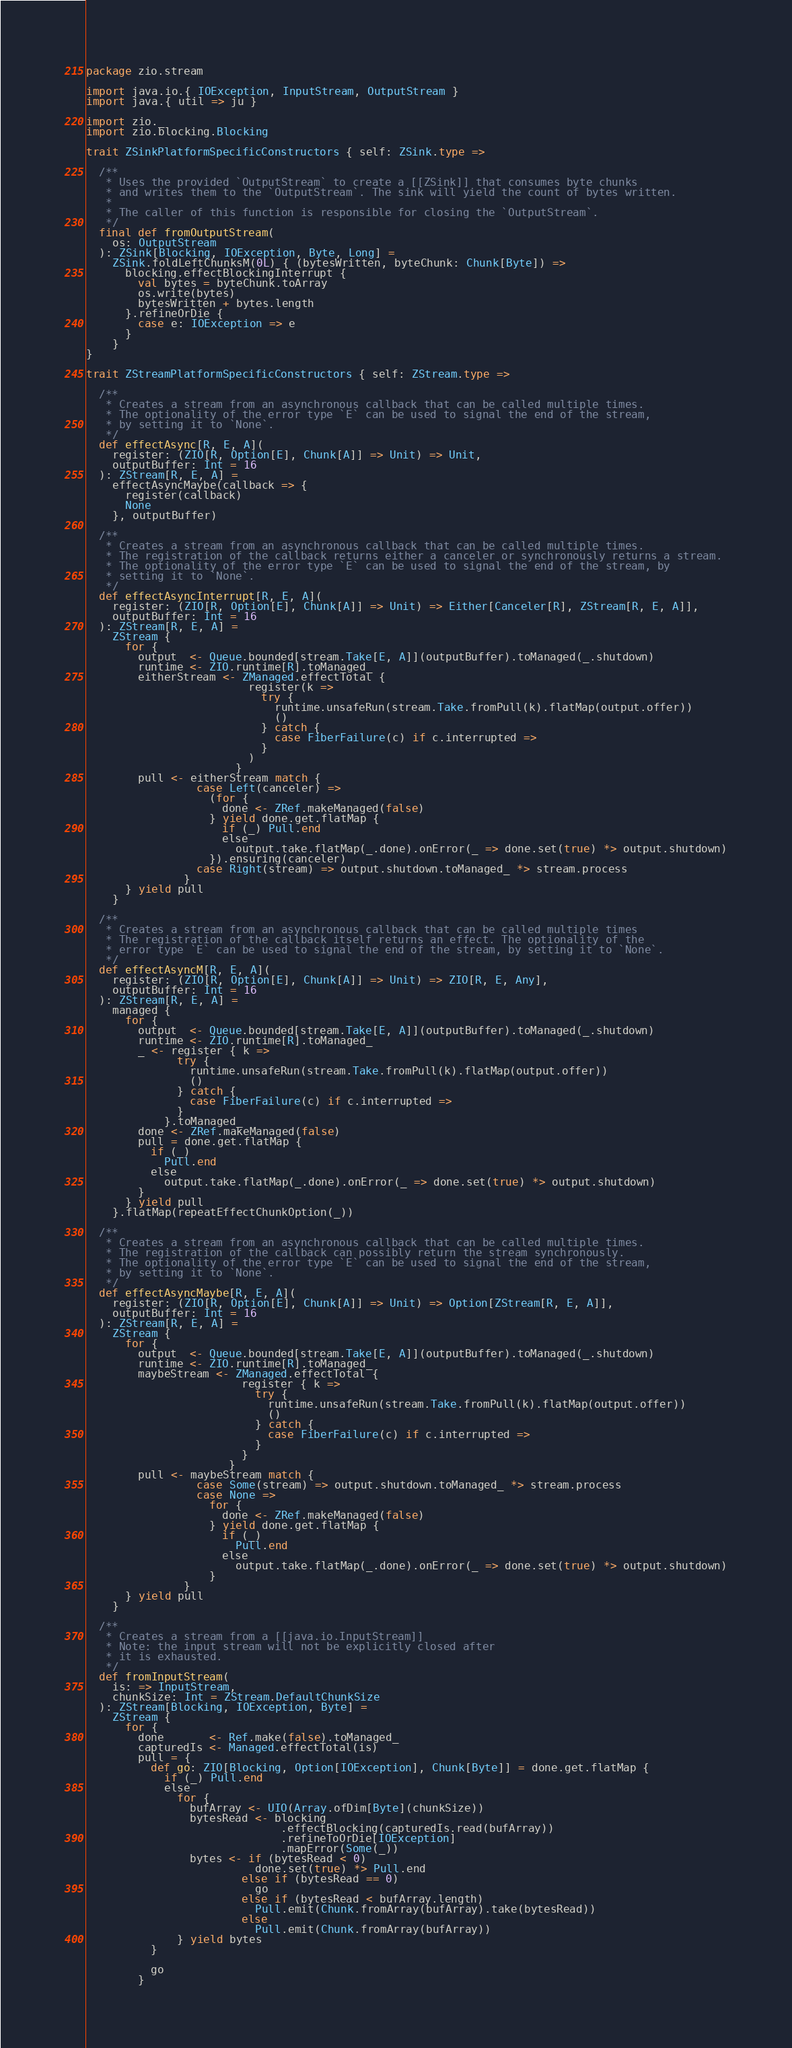Convert code to text. <code><loc_0><loc_0><loc_500><loc_500><_Scala_>package zio.stream

import java.io.{ IOException, InputStream, OutputStream }
import java.{ util => ju }

import zio._
import zio.blocking.Blocking

trait ZSinkPlatformSpecificConstructors { self: ZSink.type =>

  /**
   * Uses the provided `OutputStream` to create a [[ZSink]] that consumes byte chunks
   * and writes them to the `OutputStream`. The sink will yield the count of bytes written.
   *
   * The caller of this function is responsible for closing the `OutputStream`.
   */
  final def fromOutputStream(
    os: OutputStream
  ): ZSink[Blocking, IOException, Byte, Long] =
    ZSink.foldLeftChunksM(0L) { (bytesWritten, byteChunk: Chunk[Byte]) =>
      blocking.effectBlockingInterrupt {
        val bytes = byteChunk.toArray
        os.write(bytes)
        bytesWritten + bytes.length
      }.refineOrDie {
        case e: IOException => e
      }
    }
}

trait ZStreamPlatformSpecificConstructors { self: ZStream.type =>

  /**
   * Creates a stream from an asynchronous callback that can be called multiple times.
   * The optionality of the error type `E` can be used to signal the end of the stream,
   * by setting it to `None`.
   */
  def effectAsync[R, E, A](
    register: (ZIO[R, Option[E], Chunk[A]] => Unit) => Unit,
    outputBuffer: Int = 16
  ): ZStream[R, E, A] =
    effectAsyncMaybe(callback => {
      register(callback)
      None
    }, outputBuffer)

  /**
   * Creates a stream from an asynchronous callback that can be called multiple times.
   * The registration of the callback returns either a canceler or synchronously returns a stream.
   * The optionality of the error type `E` can be used to signal the end of the stream, by
   * setting it to `None`.
   */
  def effectAsyncInterrupt[R, E, A](
    register: (ZIO[R, Option[E], Chunk[A]] => Unit) => Either[Canceler[R], ZStream[R, E, A]],
    outputBuffer: Int = 16
  ): ZStream[R, E, A] =
    ZStream {
      for {
        output  <- Queue.bounded[stream.Take[E, A]](outputBuffer).toManaged(_.shutdown)
        runtime <- ZIO.runtime[R].toManaged_
        eitherStream <- ZManaged.effectTotal {
                         register(k =>
                           try {
                             runtime.unsafeRun(stream.Take.fromPull(k).flatMap(output.offer))
                             ()
                           } catch {
                             case FiberFailure(c) if c.interrupted =>
                           }
                         )
                       }
        pull <- eitherStream match {
                 case Left(canceler) =>
                   (for {
                     done <- ZRef.makeManaged(false)
                   } yield done.get.flatMap {
                     if (_) Pull.end
                     else
                       output.take.flatMap(_.done).onError(_ => done.set(true) *> output.shutdown)
                   }).ensuring(canceler)
                 case Right(stream) => output.shutdown.toManaged_ *> stream.process
               }
      } yield pull
    }

  /**
   * Creates a stream from an asynchronous callback that can be called multiple times
   * The registration of the callback itself returns an effect. The optionality of the
   * error type `E` can be used to signal the end of the stream, by setting it to `None`.
   */
  def effectAsyncM[R, E, A](
    register: (ZIO[R, Option[E], Chunk[A]] => Unit) => ZIO[R, E, Any],
    outputBuffer: Int = 16
  ): ZStream[R, E, A] =
    managed {
      for {
        output  <- Queue.bounded[stream.Take[E, A]](outputBuffer).toManaged(_.shutdown)
        runtime <- ZIO.runtime[R].toManaged_
        _ <- register { k =>
              try {
                runtime.unsafeRun(stream.Take.fromPull(k).flatMap(output.offer))
                ()
              } catch {
                case FiberFailure(c) if c.interrupted =>
              }
            }.toManaged_
        done <- ZRef.makeManaged(false)
        pull = done.get.flatMap {
          if (_)
            Pull.end
          else
            output.take.flatMap(_.done).onError(_ => done.set(true) *> output.shutdown)
        }
      } yield pull
    }.flatMap(repeatEffectChunkOption(_))

  /**
   * Creates a stream from an asynchronous callback that can be called multiple times.
   * The registration of the callback can possibly return the stream synchronously.
   * The optionality of the error type `E` can be used to signal the end of the stream,
   * by setting it to `None`.
   */
  def effectAsyncMaybe[R, E, A](
    register: (ZIO[R, Option[E], Chunk[A]] => Unit) => Option[ZStream[R, E, A]],
    outputBuffer: Int = 16
  ): ZStream[R, E, A] =
    ZStream {
      for {
        output  <- Queue.bounded[stream.Take[E, A]](outputBuffer).toManaged(_.shutdown)
        runtime <- ZIO.runtime[R].toManaged_
        maybeStream <- ZManaged.effectTotal {
                        register { k =>
                          try {
                            runtime.unsafeRun(stream.Take.fromPull(k).flatMap(output.offer))
                            ()
                          } catch {
                            case FiberFailure(c) if c.interrupted =>
                          }
                        }
                      }
        pull <- maybeStream match {
                 case Some(stream) => output.shutdown.toManaged_ *> stream.process
                 case None =>
                   for {
                     done <- ZRef.makeManaged(false)
                   } yield done.get.flatMap {
                     if (_)
                       Pull.end
                     else
                       output.take.flatMap(_.done).onError(_ => done.set(true) *> output.shutdown)
                   }
               }
      } yield pull
    }

  /**
   * Creates a stream from a [[java.io.InputStream]]
   * Note: the input stream will not be explicitly closed after
   * it is exhausted.
   */
  def fromInputStream(
    is: => InputStream,
    chunkSize: Int = ZStream.DefaultChunkSize
  ): ZStream[Blocking, IOException, Byte] =
    ZStream {
      for {
        done       <- Ref.make(false).toManaged_
        capturedIs <- Managed.effectTotal(is)
        pull = {
          def go: ZIO[Blocking, Option[IOException], Chunk[Byte]] = done.get.flatMap {
            if (_) Pull.end
            else
              for {
                bufArray <- UIO(Array.ofDim[Byte](chunkSize))
                bytesRead <- blocking
                              .effectBlocking(capturedIs.read(bufArray))
                              .refineToOrDie[IOException]
                              .mapError(Some(_))
                bytes <- if (bytesRead < 0)
                          done.set(true) *> Pull.end
                        else if (bytesRead == 0)
                          go
                        else if (bytesRead < bufArray.length)
                          Pull.emit(Chunk.fromArray(bufArray).take(bytesRead))
                        else
                          Pull.emit(Chunk.fromArray(bufArray))
              } yield bytes
          }

          go
        }</code> 